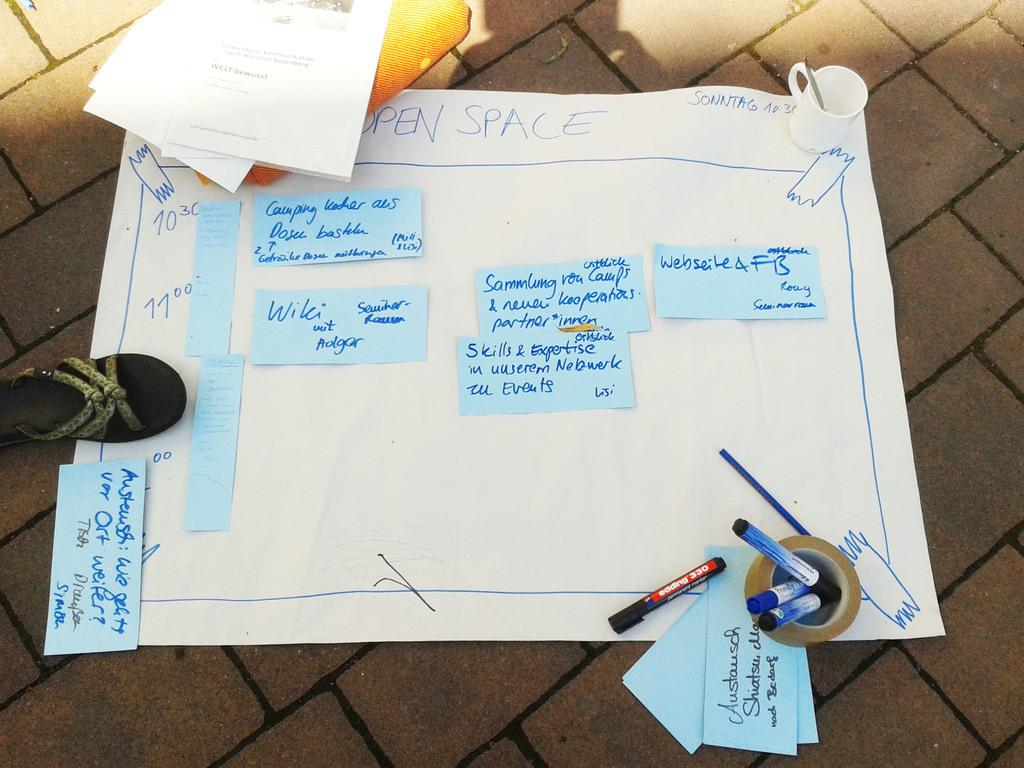What is the main subject in the middle of the image? There is a chart in the middle of the image. What can be seen on the left side of the image? There is a chappal on the left side of the image. What items are on the right side of the image? There are markers and a tape on the right side of the image. What is located at the top of the image? There is a cup at the top of the image. Is anyone driving a vehicle in the image? There is no vehicle or driving activity present in the image. Are there any signs of an attack in the image? There is no indication of an attack or any related activity in the image. 